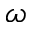Convert formula to latex. <formula><loc_0><loc_0><loc_500><loc_500>\omega</formula> 